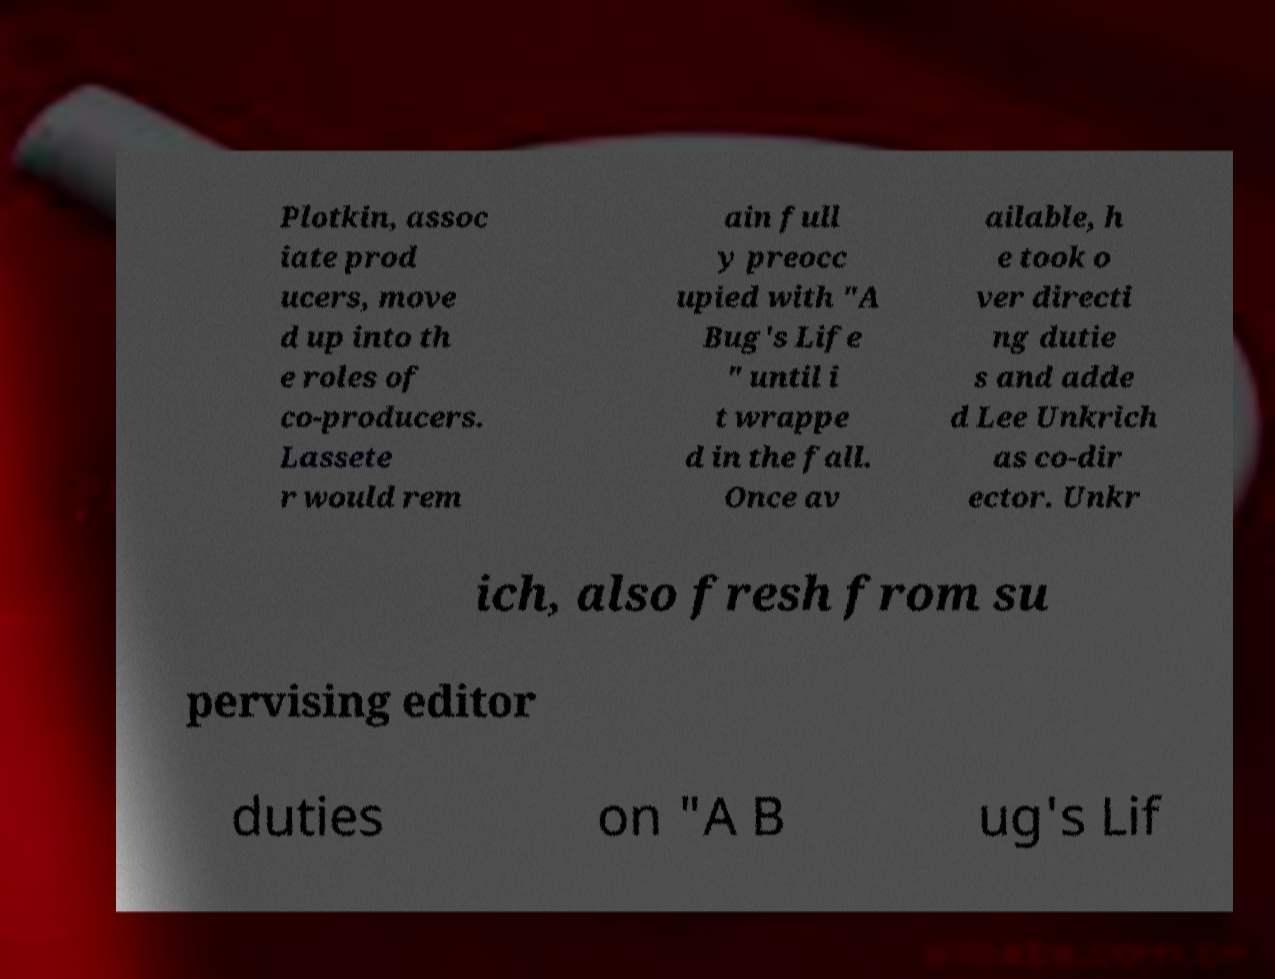Can you read and provide the text displayed in the image?This photo seems to have some interesting text. Can you extract and type it out for me? Plotkin, assoc iate prod ucers, move d up into th e roles of co-producers. Lassete r would rem ain full y preocc upied with "A Bug's Life " until i t wrappe d in the fall. Once av ailable, h e took o ver directi ng dutie s and adde d Lee Unkrich as co-dir ector. Unkr ich, also fresh from su pervising editor duties on "A B ug's Lif 